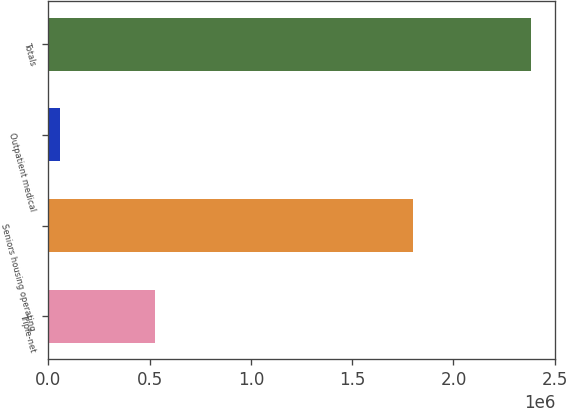Convert chart. <chart><loc_0><loc_0><loc_500><loc_500><bar_chart><fcel>Triple-net<fcel>Seniors housing operating<fcel>Outpatient medical<fcel>Totals<nl><fcel>526814<fcel>1.80145e+06<fcel>56386<fcel>2.38465e+06<nl></chart> 